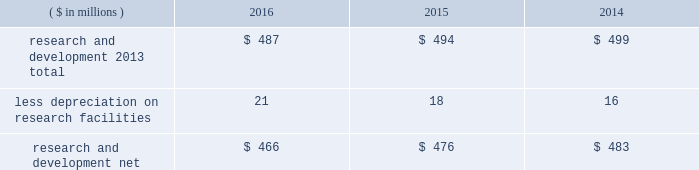Notes to the consolidated financial statements 40 2016 ppg annual report and form 10-k 1 .
Summary of significant accounting policies principles of consolidation the accompanying consolidated financial statements include the accounts of ppg industries , inc .
( 201cppg 201d or the 201ccompany 201d ) and all subsidiaries , both u.s .
And non-u.s. , that it controls .
Ppg owns more than 50% ( 50 % ) of the voting stock of most of the subsidiaries that it controls .
For those consolidated subsidiaries in which the company 2019s ownership is less than 100% ( 100 % ) , the outside shareholders 2019 interests are shown as noncontrolling interests .
Investments in companies in which ppg owns 20% ( 20 % ) to 50% ( 50 % ) of the voting stock and has the ability to exercise significant influence over operating and financial policies of the investee are accounted for using the equity method of accounting .
As a result , ppg 2019s share of the earnings or losses of such equity affiliates is included in the accompanying consolidated statement of income and ppg 2019s share of these companies 2019 shareholders 2019 equity is included in 201cinvestments 201d in the accompanying consolidated balance sheet .
Transactions between ppg and its subsidiaries are eliminated in consolidation .
Use of estimates in the preparation of financial statements the preparation of financial statements in conformity with u.s .
Generally accepted accounting principles requires management to make estimates and assumptions that affect the reported amounts of assets and liabilities and the disclosure of contingent assets and liabilities at the date of the financial statements , as well as the reported amounts of income and expenses during the reporting period .
Such estimates also include the fair value of assets acquired and liabilities assumed resulting from the allocation of the purchase price related to business combinations consummated .
Actual outcomes could differ from those estimates .
Revenue recognition the company recognizes revenue when the earnings process is complete .
Revenue is recognized by all operating segments when goods are shipped and title to inventory and risk of loss passes to the customer or when services have been rendered .
Shipping and handling costs amounts billed to customers for shipping and handling are reported in 201cnet sales 201d in the accompanying consolidated statement of income .
Shipping and handling costs incurred by the company for the delivery of goods to customers are included in 201ccost of sales , exclusive of depreciation and amortization 201d in the accompanying consolidated statement of income .
Selling , general and administrative costs amounts presented as 201cselling , general and administrative 201d in the accompanying consolidated statement of income are comprised of selling , customer service , distribution and advertising costs , as well as the costs of providing corporate- wide functional support in such areas as finance , law , human resources and planning .
Distribution costs pertain to the movement and storage of finished goods inventory at company- owned and leased warehouses and other distribution facilities .
Advertising costs advertising costs are expensed as incurred and totaled $ 322 million , $ 324 million and $ 297 million in 2016 , 2015 and 2014 , respectively .
Research and development research and development costs , which consist primarily of employee related costs , are charged to expense as incurred. .
Legal costs legal costs , primarily include costs associated with acquisition and divestiture transactions , general litigation , environmental regulation compliance , patent and trademark protection and other general corporate purposes , are charged to expense as incurred .
Foreign currency translation the functional currency of most significant non-u.s .
Operations is their local currency .
Assets and liabilities of those operations are translated into u.s .
Dollars using year-end exchange rates ; income and expenses are translated using the average exchange rates for the reporting period .
Unrealized foreign currency translation adjustments are deferred in accumulated other comprehensive loss , a separate component of shareholders 2019 equity .
Cash equivalents cash equivalents are highly liquid investments ( valued at cost , which approximates fair value ) acquired with an original maturity of three months or less .
Short-term investments short-term investments are highly liquid , high credit quality investments ( valued at cost plus accrued interest ) that have stated maturities of greater than three months to one year .
The purchases and sales of these investments are classified as investing activities in the consolidated statement of cash flows .
Marketable equity securities the company 2019s investment in marketable equity securities is recorded at fair market value and reported in 201cother current assets 201d and 201cinvestments 201d in the accompanying consolidated balance sheet with changes in fair market value recorded in income for those securities designated as trading securities and in other comprehensive income , net of tax , for those designated as available for sale securities. .
What was the percentage change in research and development net from 2014 to 2015? 
Computations: ((476 - 483) / 483)
Answer: -0.01449. 